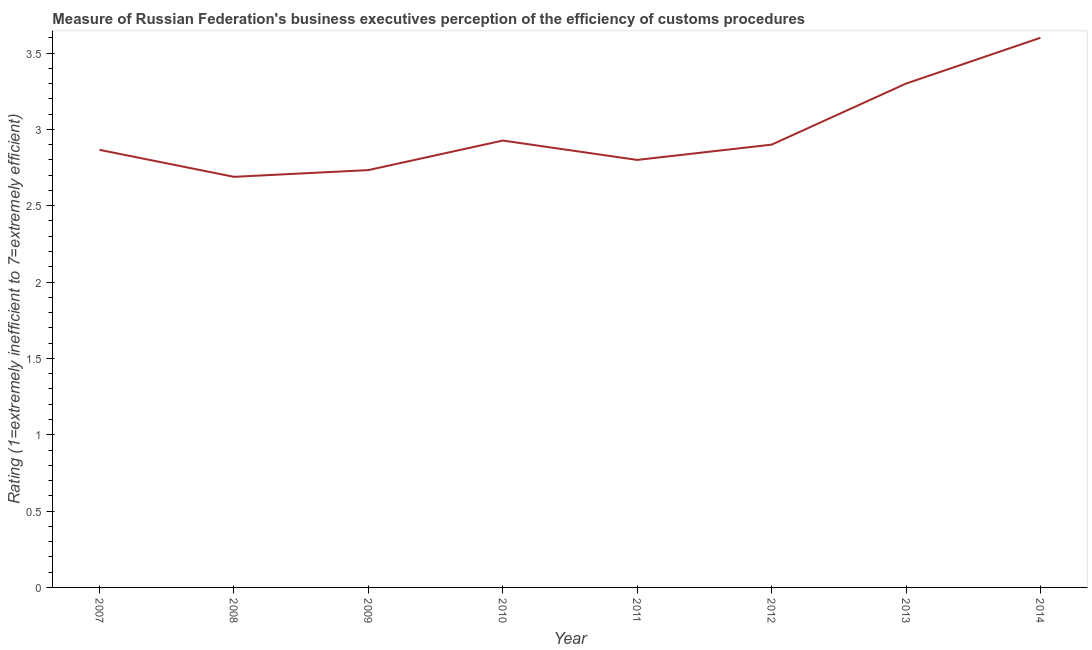What is the rating measuring burden of customs procedure in 2010?
Offer a terse response. 2.93. Across all years, what is the maximum rating measuring burden of customs procedure?
Your answer should be compact. 3.6. Across all years, what is the minimum rating measuring burden of customs procedure?
Your response must be concise. 2.69. In which year was the rating measuring burden of customs procedure minimum?
Your response must be concise. 2008. What is the sum of the rating measuring burden of customs procedure?
Ensure brevity in your answer.  23.82. What is the difference between the rating measuring burden of customs procedure in 2011 and 2012?
Provide a short and direct response. -0.1. What is the average rating measuring burden of customs procedure per year?
Your answer should be compact. 2.98. What is the median rating measuring burden of customs procedure?
Ensure brevity in your answer.  2.88. What is the ratio of the rating measuring burden of customs procedure in 2009 to that in 2012?
Keep it short and to the point. 0.94. What is the difference between the highest and the second highest rating measuring burden of customs procedure?
Ensure brevity in your answer.  0.3. What is the difference between the highest and the lowest rating measuring burden of customs procedure?
Provide a short and direct response. 0.91. In how many years, is the rating measuring burden of customs procedure greater than the average rating measuring burden of customs procedure taken over all years?
Keep it short and to the point. 2. Does the rating measuring burden of customs procedure monotonically increase over the years?
Your answer should be compact. No. How many years are there in the graph?
Your answer should be very brief. 8. What is the difference between two consecutive major ticks on the Y-axis?
Your answer should be compact. 0.5. Are the values on the major ticks of Y-axis written in scientific E-notation?
Keep it short and to the point. No. Does the graph contain grids?
Your answer should be very brief. No. What is the title of the graph?
Offer a very short reply. Measure of Russian Federation's business executives perception of the efficiency of customs procedures. What is the label or title of the Y-axis?
Give a very brief answer. Rating (1=extremely inefficient to 7=extremely efficient). What is the Rating (1=extremely inefficient to 7=extremely efficient) of 2007?
Your answer should be compact. 2.87. What is the Rating (1=extremely inefficient to 7=extremely efficient) in 2008?
Offer a terse response. 2.69. What is the Rating (1=extremely inefficient to 7=extremely efficient) in 2009?
Provide a short and direct response. 2.73. What is the Rating (1=extremely inefficient to 7=extremely efficient) in 2010?
Ensure brevity in your answer.  2.93. What is the Rating (1=extremely inefficient to 7=extremely efficient) in 2011?
Keep it short and to the point. 2.8. What is the Rating (1=extremely inefficient to 7=extremely efficient) in 2012?
Keep it short and to the point. 2.9. What is the Rating (1=extremely inefficient to 7=extremely efficient) of 2013?
Your response must be concise. 3.3. What is the difference between the Rating (1=extremely inefficient to 7=extremely efficient) in 2007 and 2008?
Ensure brevity in your answer.  0.18. What is the difference between the Rating (1=extremely inefficient to 7=extremely efficient) in 2007 and 2009?
Your answer should be compact. 0.13. What is the difference between the Rating (1=extremely inefficient to 7=extremely efficient) in 2007 and 2010?
Offer a very short reply. -0.06. What is the difference between the Rating (1=extremely inefficient to 7=extremely efficient) in 2007 and 2011?
Your answer should be very brief. 0.07. What is the difference between the Rating (1=extremely inefficient to 7=extremely efficient) in 2007 and 2012?
Offer a very short reply. -0.03. What is the difference between the Rating (1=extremely inefficient to 7=extremely efficient) in 2007 and 2013?
Keep it short and to the point. -0.43. What is the difference between the Rating (1=extremely inefficient to 7=extremely efficient) in 2007 and 2014?
Your answer should be compact. -0.73. What is the difference between the Rating (1=extremely inefficient to 7=extremely efficient) in 2008 and 2009?
Provide a short and direct response. -0.04. What is the difference between the Rating (1=extremely inefficient to 7=extremely efficient) in 2008 and 2010?
Provide a short and direct response. -0.24. What is the difference between the Rating (1=extremely inefficient to 7=extremely efficient) in 2008 and 2011?
Provide a succinct answer. -0.11. What is the difference between the Rating (1=extremely inefficient to 7=extremely efficient) in 2008 and 2012?
Offer a very short reply. -0.21. What is the difference between the Rating (1=extremely inefficient to 7=extremely efficient) in 2008 and 2013?
Provide a succinct answer. -0.61. What is the difference between the Rating (1=extremely inefficient to 7=extremely efficient) in 2008 and 2014?
Keep it short and to the point. -0.91. What is the difference between the Rating (1=extremely inefficient to 7=extremely efficient) in 2009 and 2010?
Keep it short and to the point. -0.19. What is the difference between the Rating (1=extremely inefficient to 7=extremely efficient) in 2009 and 2011?
Make the answer very short. -0.07. What is the difference between the Rating (1=extremely inefficient to 7=extremely efficient) in 2009 and 2012?
Give a very brief answer. -0.17. What is the difference between the Rating (1=extremely inefficient to 7=extremely efficient) in 2009 and 2013?
Your answer should be compact. -0.57. What is the difference between the Rating (1=extremely inefficient to 7=extremely efficient) in 2009 and 2014?
Your response must be concise. -0.87. What is the difference between the Rating (1=extremely inefficient to 7=extremely efficient) in 2010 and 2011?
Offer a very short reply. 0.13. What is the difference between the Rating (1=extremely inefficient to 7=extremely efficient) in 2010 and 2012?
Provide a succinct answer. 0.03. What is the difference between the Rating (1=extremely inefficient to 7=extremely efficient) in 2010 and 2013?
Keep it short and to the point. -0.37. What is the difference between the Rating (1=extremely inefficient to 7=extremely efficient) in 2010 and 2014?
Your answer should be compact. -0.67. What is the difference between the Rating (1=extremely inefficient to 7=extremely efficient) in 2011 and 2012?
Give a very brief answer. -0.1. What is the difference between the Rating (1=extremely inefficient to 7=extremely efficient) in 2011 and 2013?
Give a very brief answer. -0.5. What is the difference between the Rating (1=extremely inefficient to 7=extremely efficient) in 2011 and 2014?
Offer a very short reply. -0.8. What is the ratio of the Rating (1=extremely inefficient to 7=extremely efficient) in 2007 to that in 2008?
Keep it short and to the point. 1.07. What is the ratio of the Rating (1=extremely inefficient to 7=extremely efficient) in 2007 to that in 2009?
Give a very brief answer. 1.05. What is the ratio of the Rating (1=extremely inefficient to 7=extremely efficient) in 2007 to that in 2010?
Offer a very short reply. 0.98. What is the ratio of the Rating (1=extremely inefficient to 7=extremely efficient) in 2007 to that in 2011?
Ensure brevity in your answer.  1.02. What is the ratio of the Rating (1=extremely inefficient to 7=extremely efficient) in 2007 to that in 2012?
Provide a succinct answer. 0.99. What is the ratio of the Rating (1=extremely inefficient to 7=extremely efficient) in 2007 to that in 2013?
Keep it short and to the point. 0.87. What is the ratio of the Rating (1=extremely inefficient to 7=extremely efficient) in 2007 to that in 2014?
Provide a short and direct response. 0.8. What is the ratio of the Rating (1=extremely inefficient to 7=extremely efficient) in 2008 to that in 2009?
Provide a succinct answer. 0.98. What is the ratio of the Rating (1=extremely inefficient to 7=extremely efficient) in 2008 to that in 2010?
Make the answer very short. 0.92. What is the ratio of the Rating (1=extremely inefficient to 7=extremely efficient) in 2008 to that in 2011?
Your answer should be compact. 0.96. What is the ratio of the Rating (1=extremely inefficient to 7=extremely efficient) in 2008 to that in 2012?
Your answer should be compact. 0.93. What is the ratio of the Rating (1=extremely inefficient to 7=extremely efficient) in 2008 to that in 2013?
Ensure brevity in your answer.  0.81. What is the ratio of the Rating (1=extremely inefficient to 7=extremely efficient) in 2008 to that in 2014?
Your response must be concise. 0.75. What is the ratio of the Rating (1=extremely inefficient to 7=extremely efficient) in 2009 to that in 2010?
Give a very brief answer. 0.93. What is the ratio of the Rating (1=extremely inefficient to 7=extremely efficient) in 2009 to that in 2011?
Provide a short and direct response. 0.98. What is the ratio of the Rating (1=extremely inefficient to 7=extremely efficient) in 2009 to that in 2012?
Your response must be concise. 0.94. What is the ratio of the Rating (1=extremely inefficient to 7=extremely efficient) in 2009 to that in 2013?
Provide a succinct answer. 0.83. What is the ratio of the Rating (1=extremely inefficient to 7=extremely efficient) in 2009 to that in 2014?
Offer a very short reply. 0.76. What is the ratio of the Rating (1=extremely inefficient to 7=extremely efficient) in 2010 to that in 2011?
Your answer should be very brief. 1.04. What is the ratio of the Rating (1=extremely inefficient to 7=extremely efficient) in 2010 to that in 2012?
Your answer should be very brief. 1.01. What is the ratio of the Rating (1=extremely inefficient to 7=extremely efficient) in 2010 to that in 2013?
Your answer should be very brief. 0.89. What is the ratio of the Rating (1=extremely inefficient to 7=extremely efficient) in 2010 to that in 2014?
Make the answer very short. 0.81. What is the ratio of the Rating (1=extremely inefficient to 7=extremely efficient) in 2011 to that in 2013?
Your response must be concise. 0.85. What is the ratio of the Rating (1=extremely inefficient to 7=extremely efficient) in 2011 to that in 2014?
Your answer should be compact. 0.78. What is the ratio of the Rating (1=extremely inefficient to 7=extremely efficient) in 2012 to that in 2013?
Provide a succinct answer. 0.88. What is the ratio of the Rating (1=extremely inefficient to 7=extremely efficient) in 2012 to that in 2014?
Provide a succinct answer. 0.81. What is the ratio of the Rating (1=extremely inefficient to 7=extremely efficient) in 2013 to that in 2014?
Ensure brevity in your answer.  0.92. 